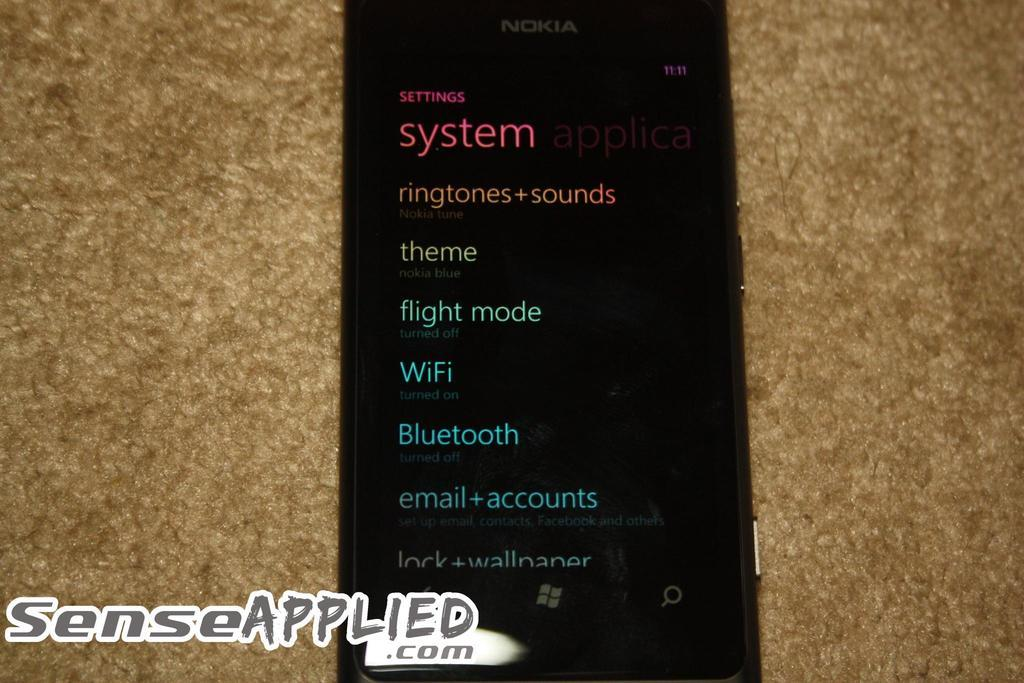<image>
Share a concise interpretation of the image provided. A black Nokia brand cellphone with the settings screen being displayed 